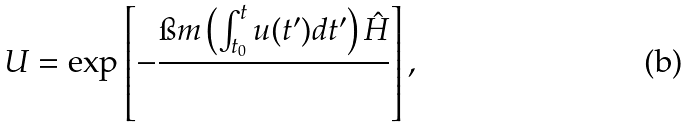<formula> <loc_0><loc_0><loc_500><loc_500>U = \exp \left [ - \frac { \i m \left ( \int _ { t _ { 0 } } ^ { t } u ( t ^ { \prime } ) d t ^ { \prime } \right ) \hat { H } } { } \right ] ,</formula> 